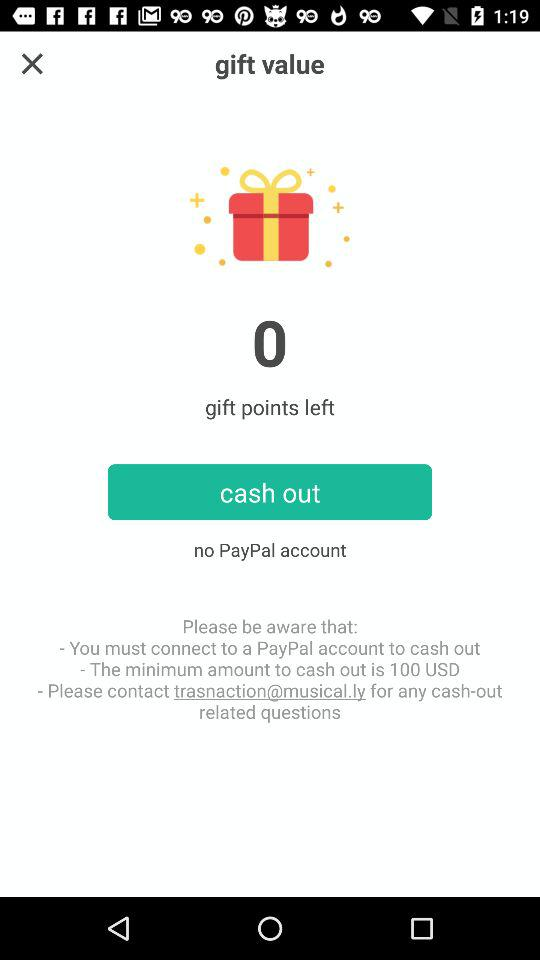What email address should be used for any questions related to cash-outs? The email address that should be used for any questions related to cash-outs is trasnaction@musical.ly. 